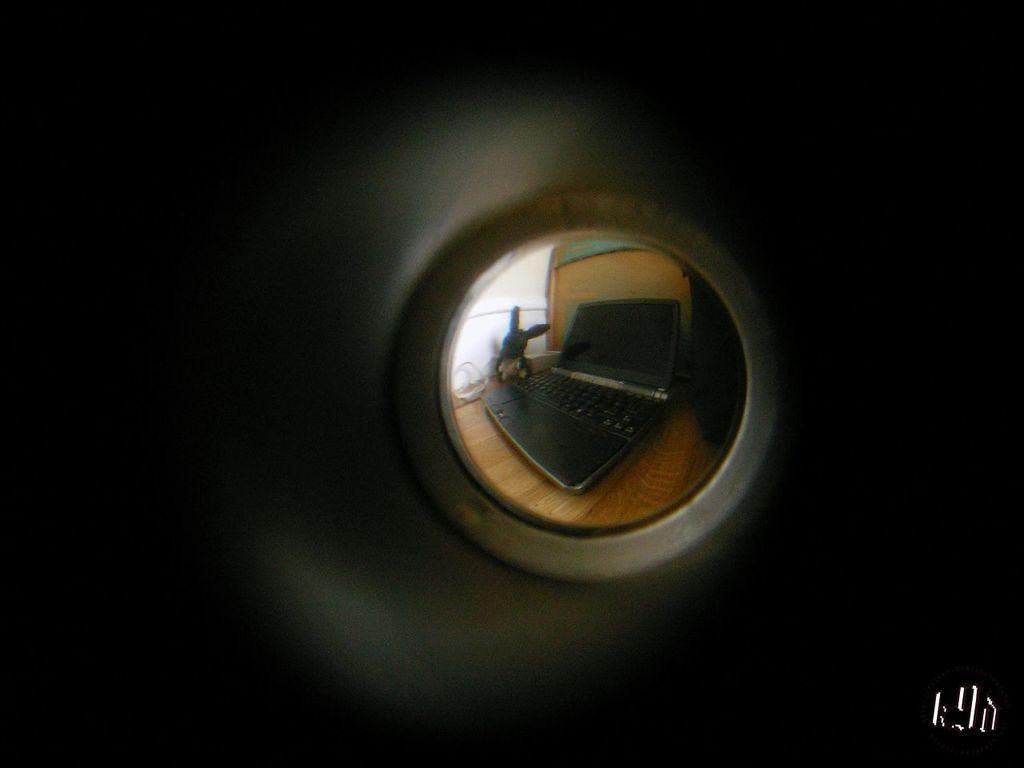Can you describe this image briefly? In this picture we can see a laptop, toy on a wooden surface and some objects and in the background it is dark. 